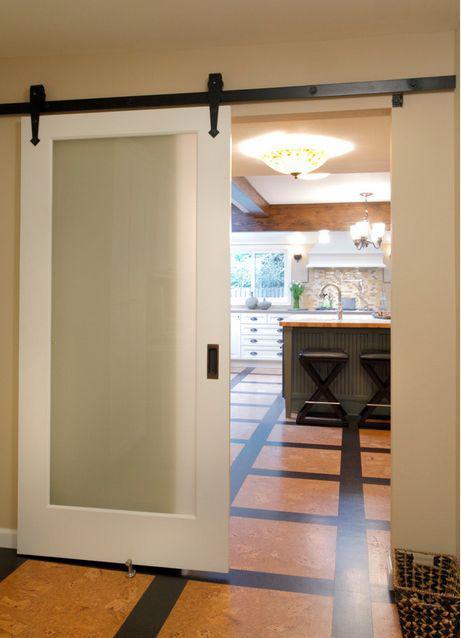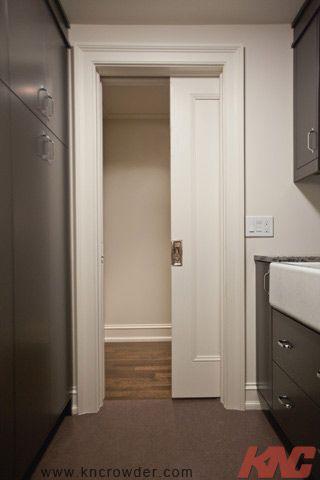The first image is the image on the left, the second image is the image on the right. For the images displayed, is the sentence "One sliding door is partially open and showing a bathroom behind it." factually correct? Answer yes or no. No. The first image is the image on the left, the second image is the image on the right. Examine the images to the left and right. Is the description "One image shows a doorway with a single white door in a head-on view, and the door is half-closed with the left half open." accurate? Answer yes or no. Yes. 